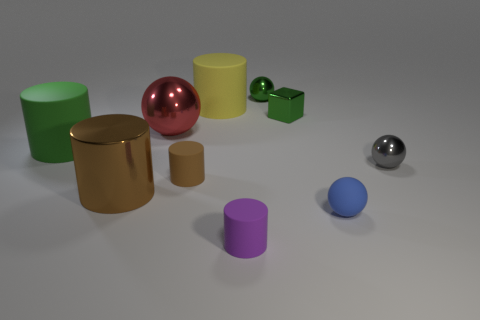What size is the cylinder in front of the small blue sphere?
Give a very brief answer. Small. Is the size of the rubber thing left of the small brown matte cylinder the same as the metallic sphere that is to the left of the green shiny ball?
Your answer should be compact. Yes. What number of small brown cylinders have the same material as the purple thing?
Offer a very short reply. 1. What is the color of the tiny cube?
Offer a terse response. Green. Are there any gray balls in front of the big brown cylinder?
Provide a succinct answer. No. Is the color of the metallic block the same as the matte sphere?
Provide a succinct answer. No. How many small shiny blocks have the same color as the rubber sphere?
Offer a terse response. 0. There is a rubber cylinder in front of the large thing that is in front of the small gray metal thing; how big is it?
Offer a very short reply. Small. The small blue thing is what shape?
Ensure brevity in your answer.  Sphere. What is the small ball that is on the left side of the cube made of?
Offer a very short reply. Metal. 